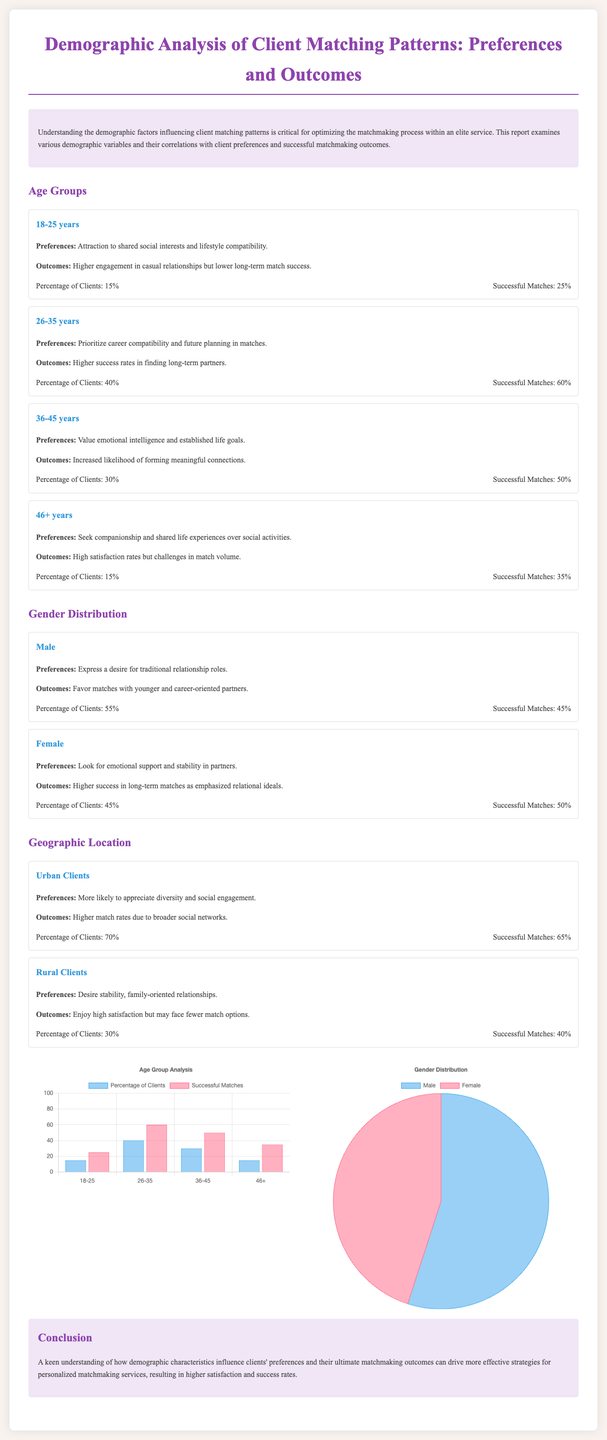What is the percentage of clients aged 26-35? The document states that the percentage of clients aged 26-35 is 40%.
Answer: 40% What are the successful matches for clients aged 18-25? According to the document, the successful matches for clients aged 18-25 are 25%.
Answer: 25% What preference do clients aged 36-45 value? Clients aged 36-45 value emotional intelligence and established life goals.
Answer: Emotional intelligence What is the percentage of female clients? The document indicates that the percentage of female clients is 45%.
Answer: 45% Which demographic section has the highest percentage of clients? The urban clients section has the highest percentage at 70%.
Answer: Urban Clients What is the outcome for male clients in terms of successful matches? The document states that successful matches for male clients are 45%.
Answer: 45% What preference do clients aged 46+ seek? Clients aged 46+ seek companionship and shared life experiences.
Answer: Companionship Which age group has the highest successful match rate? The age group 26-35 has the highest successful match rate at 60%.
Answer: 60% What demographic factor is most related to higher match rates? Geographic location, specifically urban clients, is most related to higher match rates.
Answer: Geographic location 